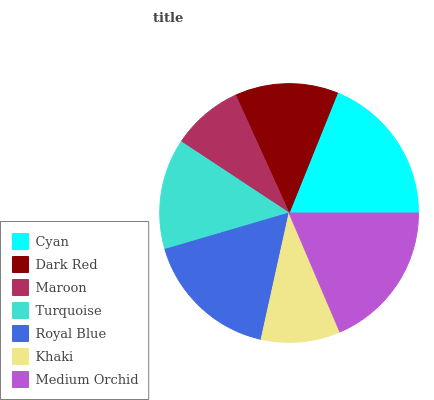Is Maroon the minimum?
Answer yes or no. Yes. Is Cyan the maximum?
Answer yes or no. Yes. Is Dark Red the minimum?
Answer yes or no. No. Is Dark Red the maximum?
Answer yes or no. No. Is Cyan greater than Dark Red?
Answer yes or no. Yes. Is Dark Red less than Cyan?
Answer yes or no. Yes. Is Dark Red greater than Cyan?
Answer yes or no. No. Is Cyan less than Dark Red?
Answer yes or no. No. Is Turquoise the high median?
Answer yes or no. Yes. Is Turquoise the low median?
Answer yes or no. Yes. Is Medium Orchid the high median?
Answer yes or no. No. Is Dark Red the low median?
Answer yes or no. No. 